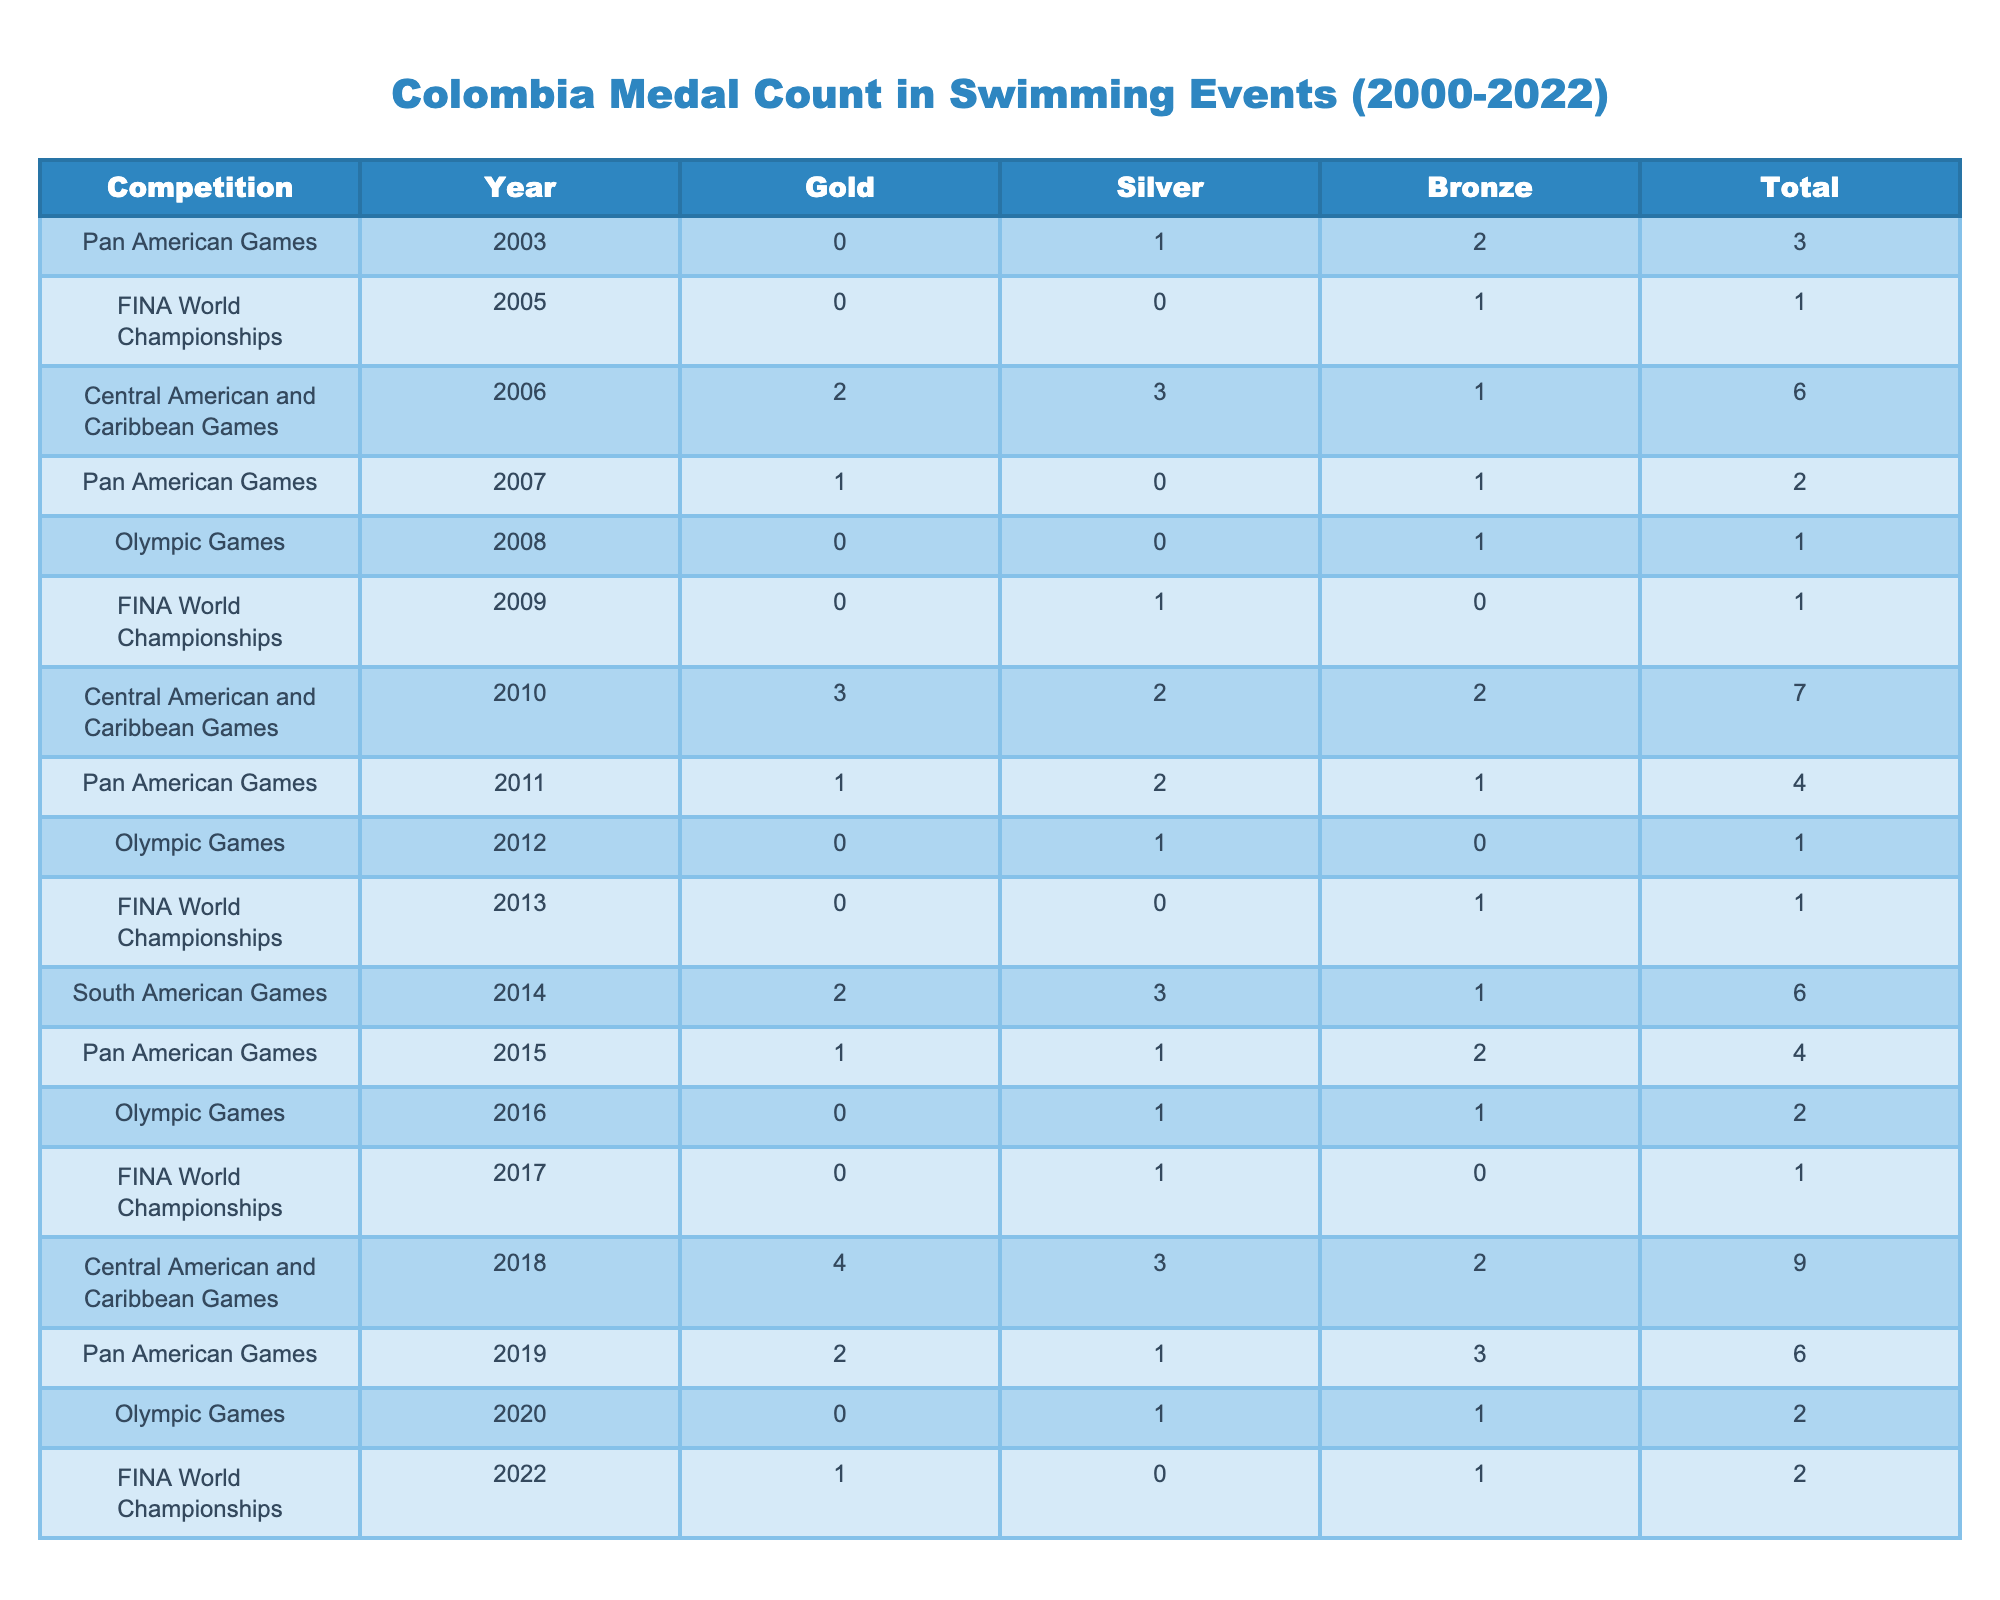What is the total number of medals won by Colombia in the Olympic Games from 2008 to 2020? To find the total number of medals won by Colombia in the Olympic Games, I will sum up the Total medals for each year from the table: 1 (2008) + 1 (2012) + 2 (2016) + 2 (2020) = 6.
Answer: 6 How many gold medals did Colombia win at the Central American and Caribbean Games in 2010? According to the table, Colombia won 3 gold medals in the Central American and Caribbean Games in 2010.
Answer: 3 Did Colombia win more silver medals at the Pan American Games in 2011 or 2015? In 2011, Colombia won 2 silver medals, and in 2015, they won 1 silver medal. Since 2 > 1, Colombia won more silver medals in 2011 than in 2015.
Answer: Yes What is the difference in the total number of medals won by Colombia at the Pan American Games in 2015 and 2019? For the Pan American Games in 2015, Colombia won a total of 4 medals (1 gold, 1 silver, 2 bronze). In 2019, they won a total of 6 medals (2 gold, 1 silver, 3 bronze). The difference is 6 - 4 = 2.
Answer: 2 Which competition year had the highest total medal count for Colombia, and how many medals were won? Looking through the table, the highest total medal count is 9, which occurred in 2018 at the Central American and Caribbean Games.
Answer: 2018, 9 What was the average number of bronze medals won by Colombia at the FINA World Championships from 2005 to 2022? The bronze medal counts at the FINA World Championships are 1 (2005), 0 (2009), 1 (2013), 0 (2017), and 1 (2022), which gives us a total of 3 bronze medals over 5 competitions. The average is 3/5 = 0.6.
Answer: 0.6 In which year did Colombia first win gold medals at the Central American and Caribbean Games, and how many were won? Colombia first won gold medals at the Central American and Caribbean Games in 2006, where they won 2 gold medals.
Answer: 2006, 2 How many total medals did Colombia win at the Olympic Games in comparison to the FINA World Championships from 2005 to 2022? From 2008 to 2020, Colombia won a total of 6 medals at the Olympic Games, while in the FINA World Championships from 2005 to 2022, they won a total of 5 medals. Therefore, Olympic Games medals > FINA World Championships medals.
Answer: Olympic Games more медалs What was the total count of silver medals won by Colombia across all competitions listed in the table? Summing all silver medals: 1 (2003) + 0 (2005) + 3 (2006) + 0 (2007) + 0 (2008) + 1 (2009) + 2 (2010) + 2 (2011) + 1 (2012) + 0 (2013) + 3 (2014) + 1 (2015) + 1 (2016) + 1 (2017) + 3 (2018) + 1 (2019) + 1 (2020) + 0 (2022) = 20 silver medals won overall.
Answer: 20 Which event saw the maximum number of medals (gold, silver, and bronze combined) for Colombia? The maximum number of medals was 9, achieved at the Central American and Caribbean Games in 2018, as noted in the Total column.
Answer: Central American and Caribbean Games 2018 